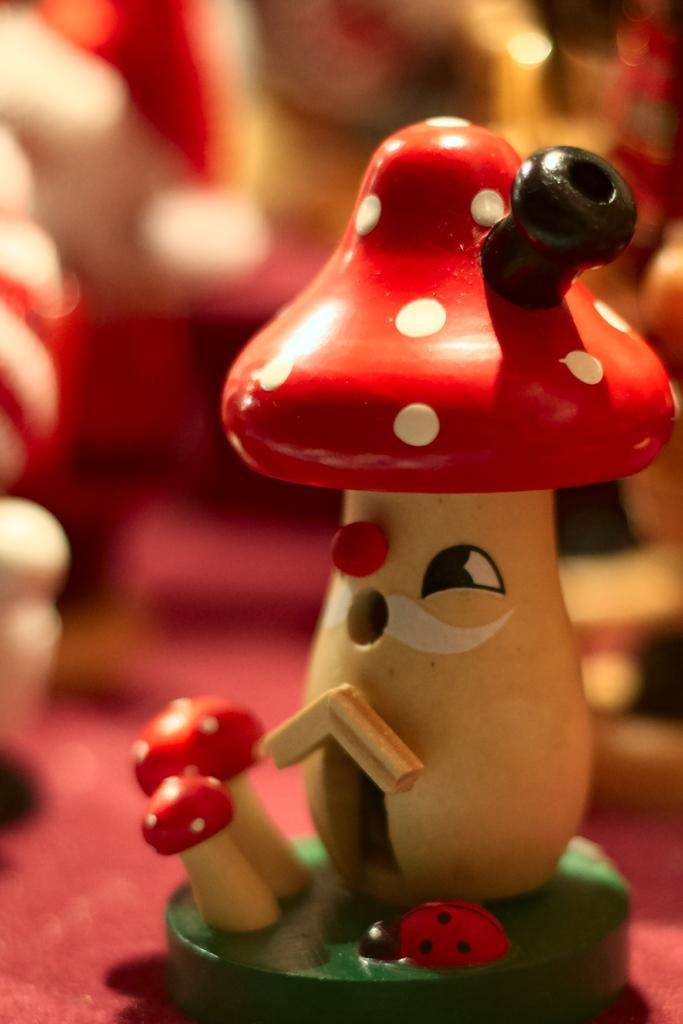Can you describe this image briefly? In this image I see the depiction of mushrooms and an insect and I see that it is blurred in the background. 